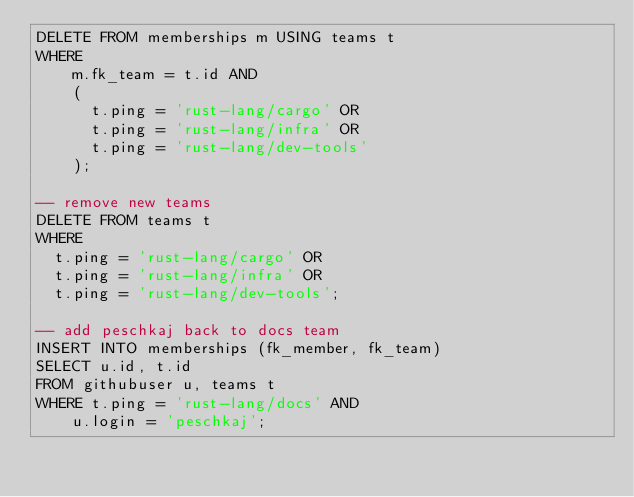<code> <loc_0><loc_0><loc_500><loc_500><_SQL_>DELETE FROM memberships m USING teams t
WHERE
    m.fk_team = t.id AND
    (
      t.ping = 'rust-lang/cargo' OR
      t.ping = 'rust-lang/infra' OR
      t.ping = 'rust-lang/dev-tools'
    );

-- remove new teams
DELETE FROM teams t
WHERE
  t.ping = 'rust-lang/cargo' OR
  t.ping = 'rust-lang/infra' OR
  t.ping = 'rust-lang/dev-tools';

-- add peschkaj back to docs team
INSERT INTO memberships (fk_member, fk_team)
SELECT u.id, t.id
FROM githubuser u, teams t
WHERE t.ping = 'rust-lang/docs' AND
    u.login = 'peschkaj';
</code> 